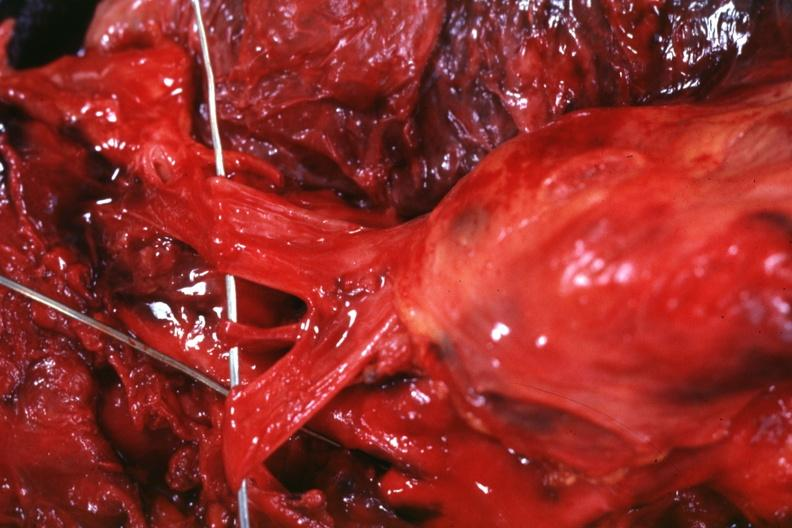where is this part in?
Answer the question using a single word or phrase. Thymus 